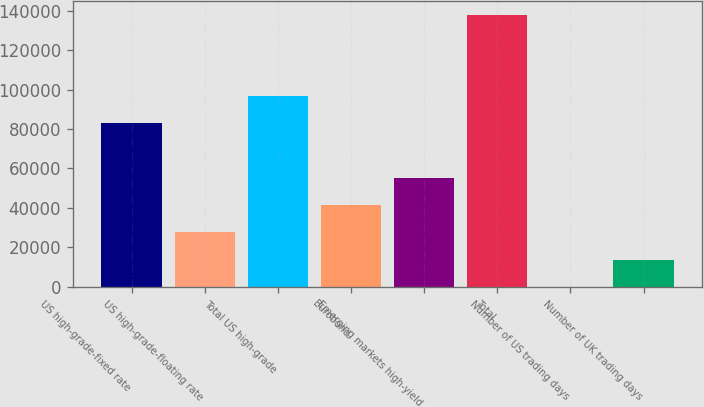Convert chart to OTSL. <chart><loc_0><loc_0><loc_500><loc_500><bar_chart><fcel>US high-grade-fixed rate<fcel>US high-grade-floating rate<fcel>Total US high-grade<fcel>Eurobond<fcel>Emerging markets high-yield<fcel>Total<fcel>Number of US trading days<fcel>Number of UK trading days<nl><fcel>83193<fcel>27600.8<fcel>96961.9<fcel>41369.7<fcel>55138.6<fcel>137752<fcel>63<fcel>13831.9<nl></chart> 